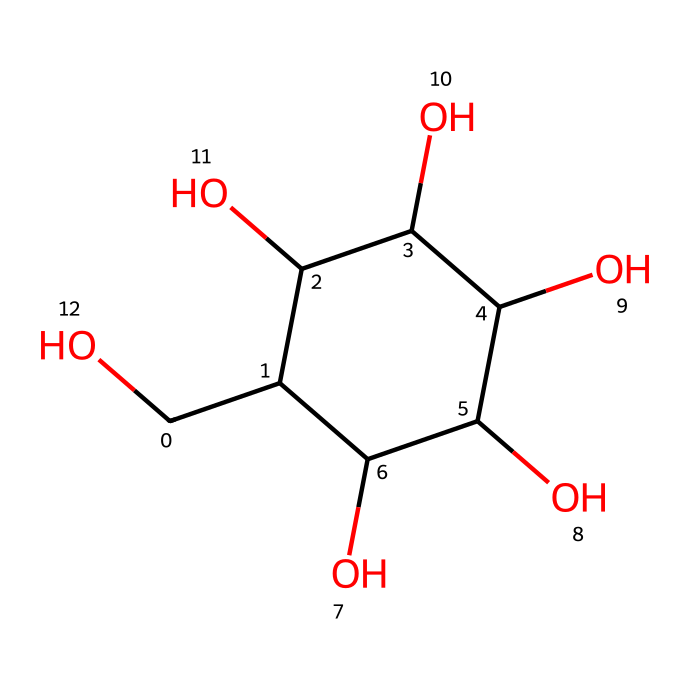What is the molecular formula of glucose? To determine the molecular formula, we need to identify the number of each type of atom from the SMILES representation. In the provided SMILES, we count 6 carbon (C), 12 hydrogen (H), and 6 oxygen (O) atoms. Thus, the molecular formula is C6H12O6.
Answer: C6H12O6 How many hydroxyl (–OH) groups are present in glucose? The SMILES representation shows multiple instances of oxygen connected to hydrogen, indicating hydroxyl groups. Counting these, we find there are 5 hydroxyl groups in the structure.
Answer: 5 What type of carbohydrate is glucose? Glucose is classified as a monosaccharide, which is a simple sugar molecule and serves as a fundamental building block for more complex carbohydrates.
Answer: monosaccharide What is the significance of glucose for athletes? Glucose is vital for athletes as it serves as a primary energy source, particularly during intense physical activity, providing quick and easily accessible energy.
Answer: energy source How many rings are present in glucose's structure? The SMILES code indicates that glucose forms a single ring structure, which is characteristic of its cyclic form, particularly as a hexose sugar.
Answer: 1 Is glucose soluble in water? Due to the presence of multiple hydroxyl groups (-OH), glucose is highly soluble in water, allowing it to easily transport in bodily fluids.
Answer: yes How many asymmetric carbon atoms does glucose have? In the structure, there are 4 carbon atoms that have four different substituents, making them chiral centers. This indicates that glucose has 4 asymmetric carbon atoms.
Answer: 4 